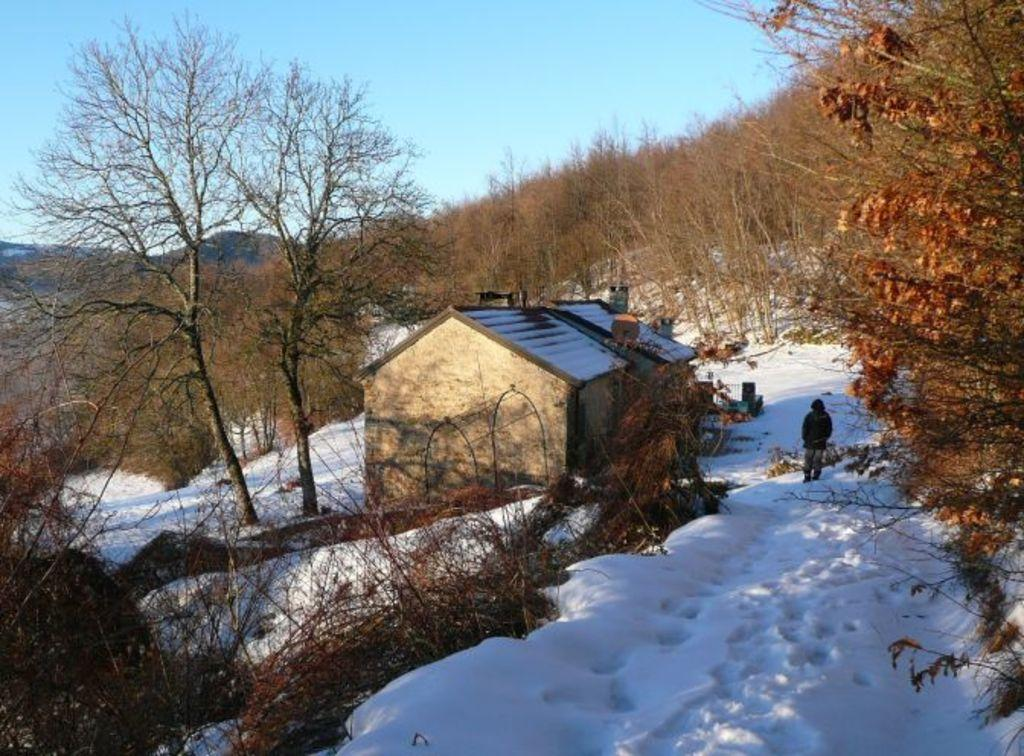What type of structure is visible in the image? There is a building in the image. Can you describe the person in the image? There is a person in the image. What type of natural environment is depicted in the image? There are many trees and hills in the image. What is the condition of the ground in the image? The ground has snow in the image. What is the condition of the sky in the image? The sky is clear in the image. How many dogs are there in the image, and what are they doing? There are no dogs present in the image. Can you describe the care and kiss between the person and the building in the image? There is no care or kiss between the person and the building in the image. 